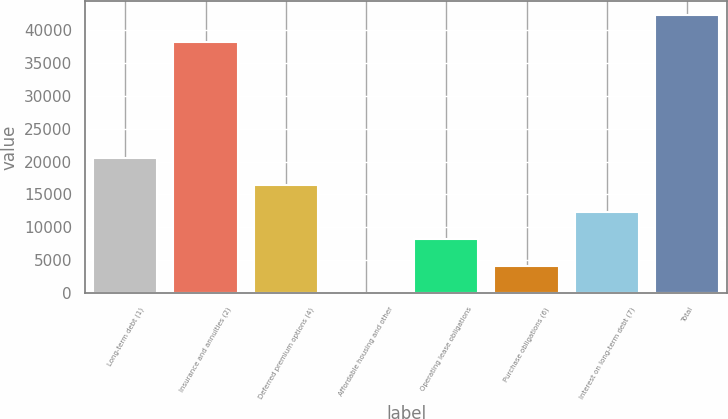Convert chart. <chart><loc_0><loc_0><loc_500><loc_500><bar_chart><fcel>Long-term debt (1)<fcel>Insurance and annuities (2)<fcel>Deferred premium options (4)<fcel>Affordable housing and other<fcel>Operating lease obligations<fcel>Purchase obligations (6)<fcel>Interest on long-term debt (7)<fcel>Total<nl><fcel>20472<fcel>38222<fcel>16378.8<fcel>6<fcel>8192.4<fcel>4099.2<fcel>12285.6<fcel>42315.2<nl></chart> 